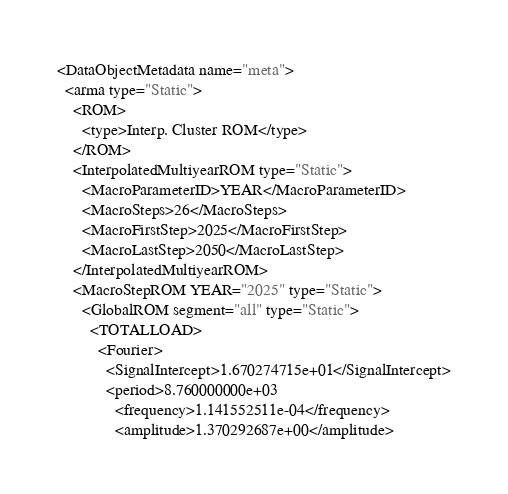Convert code to text. <code><loc_0><loc_0><loc_500><loc_500><_XML_><DataObjectMetadata name="meta">
  <arma type="Static">
    <ROM>
      <type>Interp. Cluster ROM</type>
    </ROM>
    <InterpolatedMultiyearROM type="Static">
      <MacroParameterID>YEAR</MacroParameterID>
      <MacroSteps>26</MacroSteps>
      <MacroFirstStep>2025</MacroFirstStep>
      <MacroLastStep>2050</MacroLastStep>
    </InterpolatedMultiyearROM>
    <MacroStepROM YEAR="2025" type="Static">
      <GlobalROM segment="all" type="Static">
        <TOTALLOAD>
          <Fourier>
            <SignalIntercept>1.670274715e+01</SignalIntercept>
            <period>8.760000000e+03
              <frequency>1.141552511e-04</frequency>
              <amplitude>1.370292687e+00</amplitude></code> 